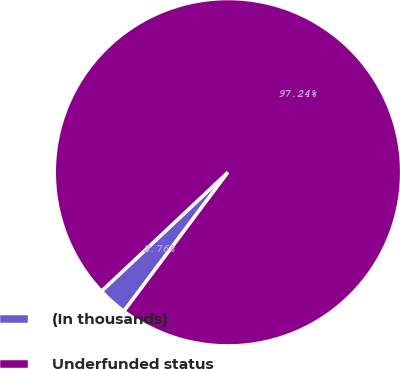Convert chart to OTSL. <chart><loc_0><loc_0><loc_500><loc_500><pie_chart><fcel>(In thousands)<fcel>Underfunded status<nl><fcel>2.76%<fcel>97.24%<nl></chart> 